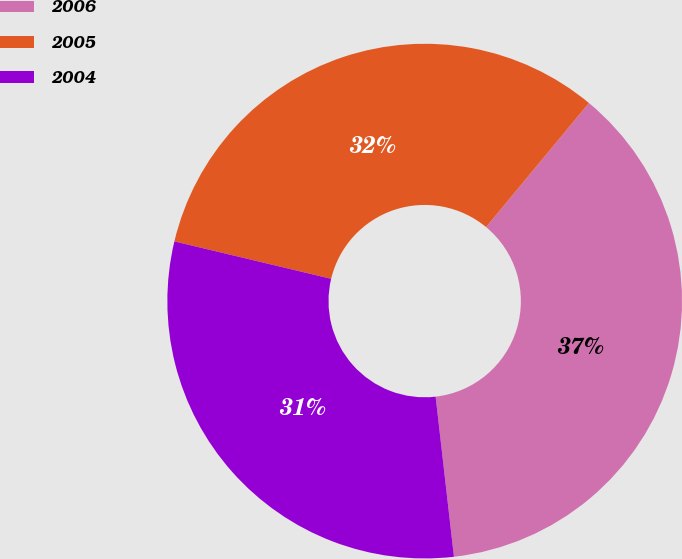<chart> <loc_0><loc_0><loc_500><loc_500><pie_chart><fcel>2006<fcel>2005<fcel>2004<nl><fcel>37.17%<fcel>32.29%<fcel>30.54%<nl></chart> 